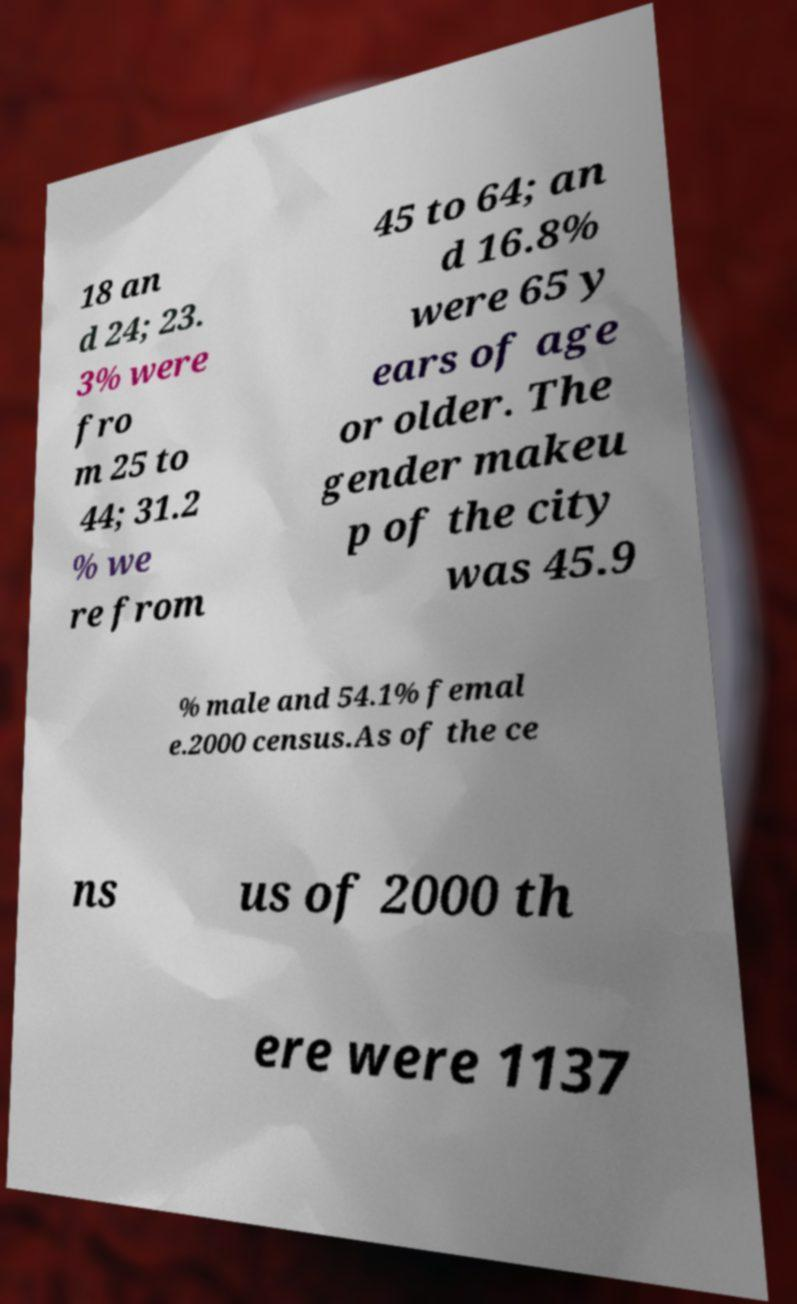Could you assist in decoding the text presented in this image and type it out clearly? 18 an d 24; 23. 3% were fro m 25 to 44; 31.2 % we re from 45 to 64; an d 16.8% were 65 y ears of age or older. The gender makeu p of the city was 45.9 % male and 54.1% femal e.2000 census.As of the ce ns us of 2000 th ere were 1137 